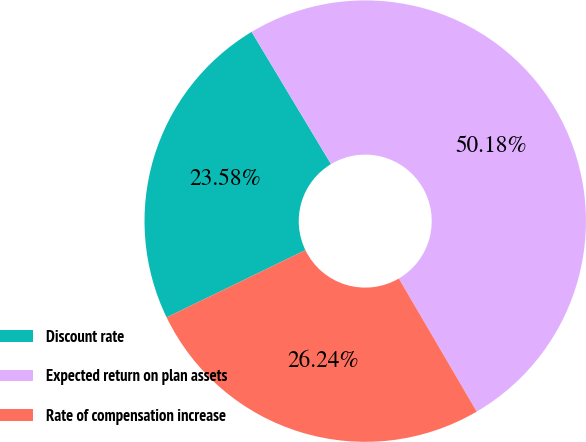Convert chart. <chart><loc_0><loc_0><loc_500><loc_500><pie_chart><fcel>Discount rate<fcel>Expected return on plan assets<fcel>Rate of compensation increase<nl><fcel>23.58%<fcel>50.18%<fcel>26.24%<nl></chart> 